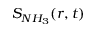Convert formula to latex. <formula><loc_0><loc_0><loc_500><loc_500>S _ { N H _ { 3 } } ( r , t )</formula> 